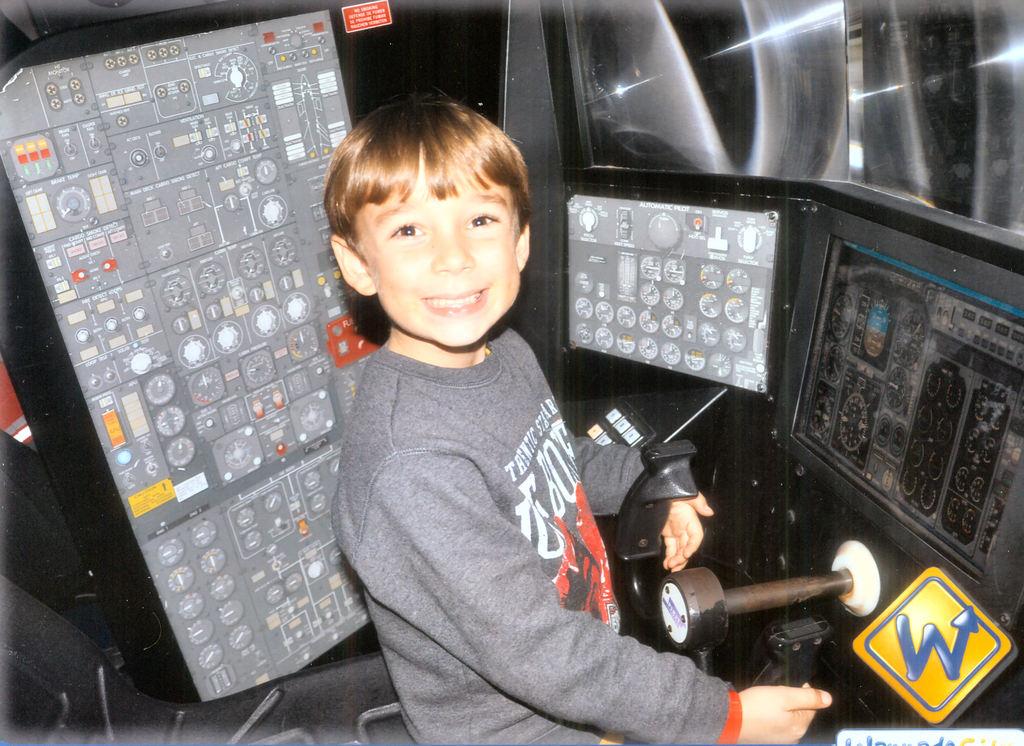What letter is prominently displayed?
Provide a short and direct response. W. What is the first letter on the boys shirt?
Offer a terse response. T. 